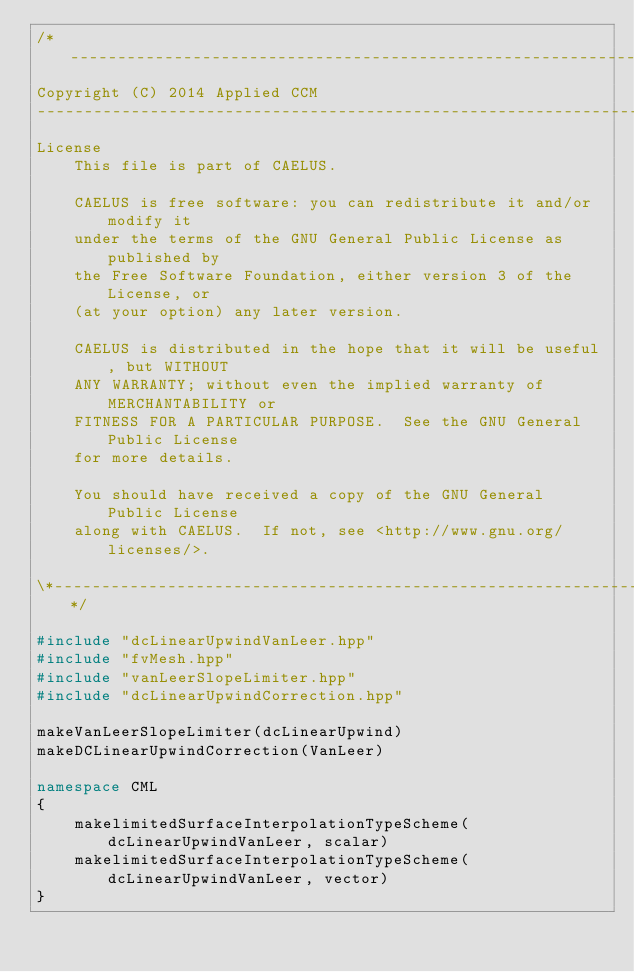Convert code to text. <code><loc_0><loc_0><loc_500><loc_500><_C++_>/*---------------------------------------------------------------------------*\
Copyright (C) 2014 Applied CCM
-------------------------------------------------------------------------------
License
    This file is part of CAELUS.

    CAELUS is free software: you can redistribute it and/or modify it
    under the terms of the GNU General Public License as published by
    the Free Software Foundation, either version 3 of the License, or
    (at your option) any later version.

    CAELUS is distributed in the hope that it will be useful, but WITHOUT
    ANY WARRANTY; without even the implied warranty of MERCHANTABILITY or
    FITNESS FOR A PARTICULAR PURPOSE.  See the GNU General Public License
    for more details.

    You should have received a copy of the GNU General Public License
    along with CAELUS.  If not, see <http://www.gnu.org/licenses/>.

\*---------------------------------------------------------------------------*/

#include "dcLinearUpwindVanLeer.hpp"
#include "fvMesh.hpp"
#include "vanLeerSlopeLimiter.hpp"
#include "dcLinearUpwindCorrection.hpp"

makeVanLeerSlopeLimiter(dcLinearUpwind)
makeDCLinearUpwindCorrection(VanLeer)

namespace CML
{
    makelimitedSurfaceInterpolationTypeScheme(dcLinearUpwindVanLeer, scalar)
    makelimitedSurfaceInterpolationTypeScheme(dcLinearUpwindVanLeer, vector)
}

</code> 